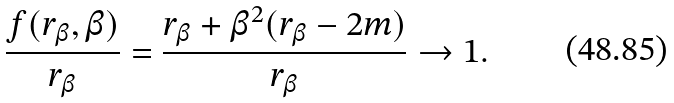<formula> <loc_0><loc_0><loc_500><loc_500>\frac { f ( r _ { \beta } , \beta ) } { r _ { \beta } } = \frac { r _ { \beta } + { \beta } ^ { 2 } ( r _ { \beta } - 2 m ) } { r _ { \beta } } \rightarrow 1 .</formula> 